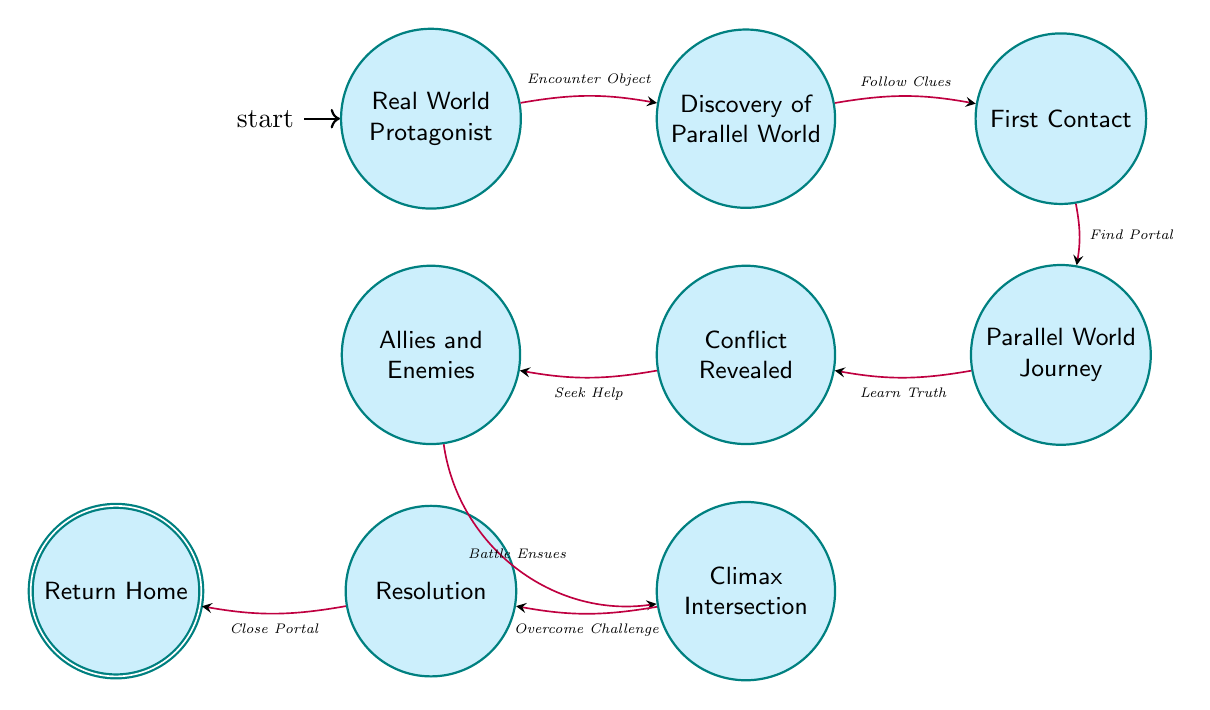What is the initial state of the protagonist? The diagram starts with the initial state labeled "Real World Protagonist," indicating the protagonist begins their journey in a mundane environment.
Answer: Real World Protagonist How many states are represented in the diagram? By counting the nodes (states) labeled in the diagram, we find there are a total of nine distinct states.
Answer: 9 What triggers the transition from "Discovery of Parallel World" to "First Contact"? The transition from "Discovery of Parallel World" to "First Contact" is triggered by the action labeled "Follow Clues," as shown by the arrow connecting the two states.
Answer: Follow Clues What is the final state the protagonist reaches after resolving the conflict? The final state after resolving the conflict is labeled "Return Home," showing the end of the protagonist's journey after all conflicts are addressed.
Answer: Return Home Which state directly follows "Climax Intersection"? The state that directly follows "Climax Intersection" is "Resolution," as indicated by the progression in the flow of the diagram.
Answer: Resolution How many transitions occur from the "Parallel World Journey" state? There is one transition that occurs from the "Parallel World Journey" state to "Conflict Revealed," indicating the result of learning more about the parallel world.
Answer: 1 What is the transition that leads to the "Climax Intersection" state? The transition leading to "Climax Intersection" from the previous state is triggered by "Battle Ensues," indicating a critical turning point in the narrative.
Answer: Battle Ensues In which state does the protagonist learn the truth? The protagonist learns the truth in the state labeled "Conflict Revealed," suggesting they gain crucial insights about the parallel world during this phase.
Answer: Conflict Revealed What is the condition to move from "Resolution" to "Return Home"? The transition from "Resolution" to "Return Home" occurs when the condition "Close Portal" is fulfilled, signaling the closing of the journey between worlds.
Answer: Close Portal 